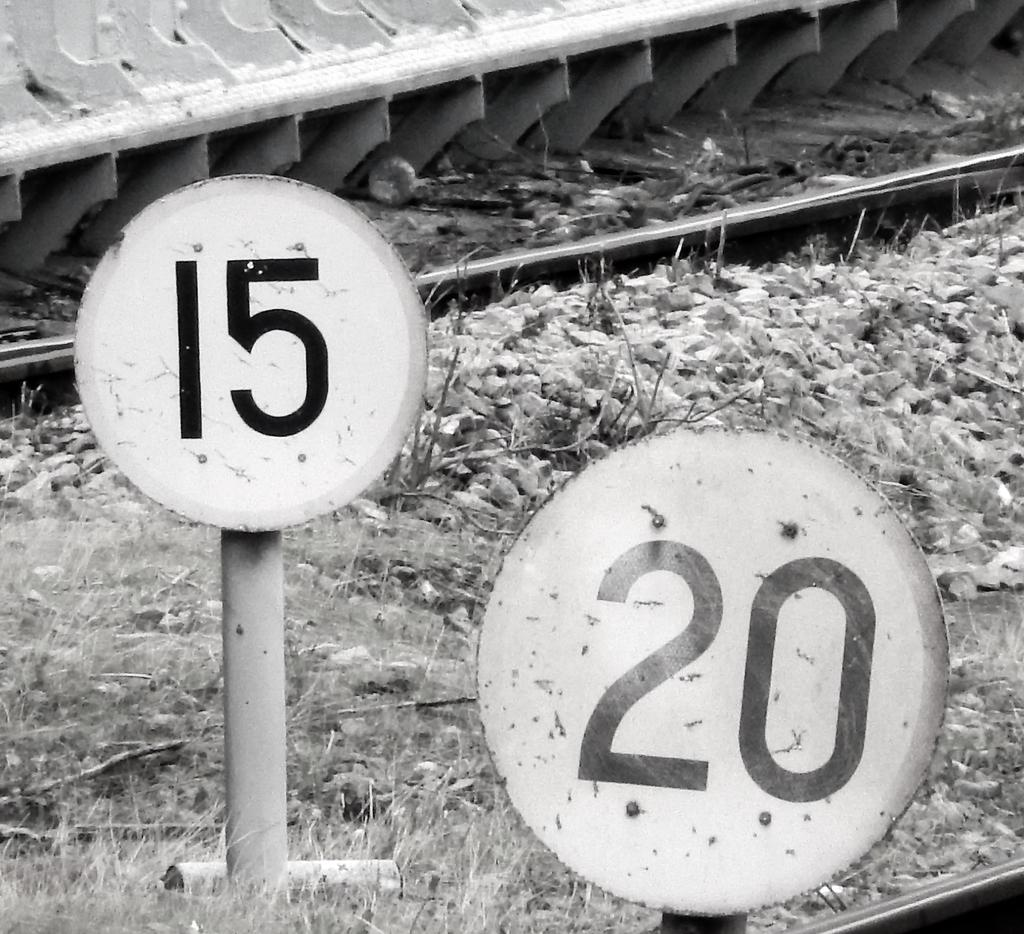<image>
Offer a succinct explanation of the picture presented. Amongst the gravel and grass a 20 is imprinted on a round sign. 